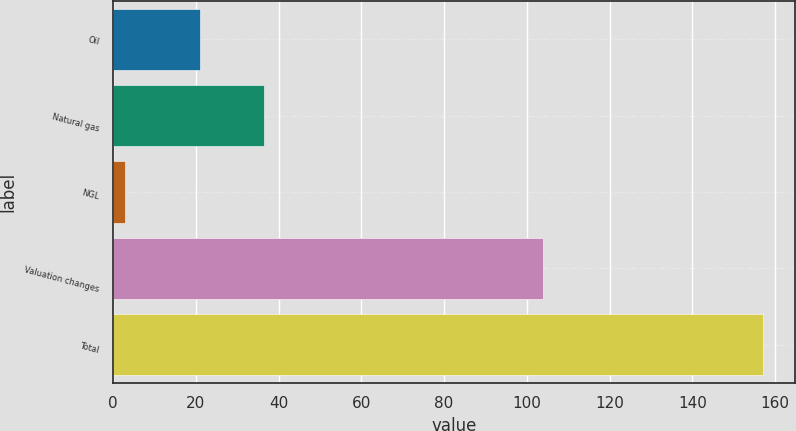Convert chart. <chart><loc_0><loc_0><loc_500><loc_500><bar_chart><fcel>Oil<fcel>Natural gas<fcel>NGL<fcel>Valuation changes<fcel>Total<nl><fcel>21<fcel>36.4<fcel>3<fcel>104<fcel>157<nl></chart> 